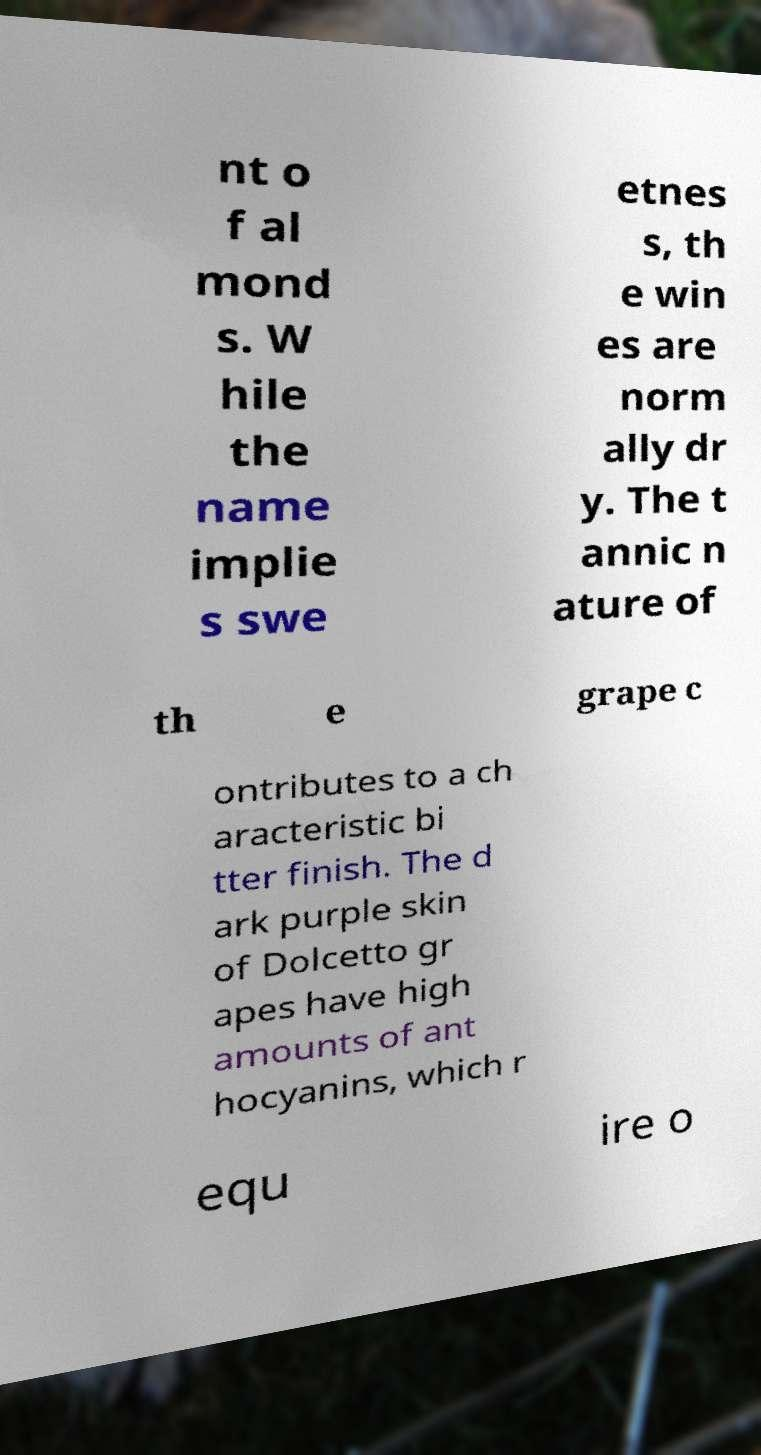What messages or text are displayed in this image? I need them in a readable, typed format. nt o f al mond s. W hile the name implie s swe etnes s, th e win es are norm ally dr y. The t annic n ature of th e grape c ontributes to a ch aracteristic bi tter finish. The d ark purple skin of Dolcetto gr apes have high amounts of ant hocyanins, which r equ ire o 